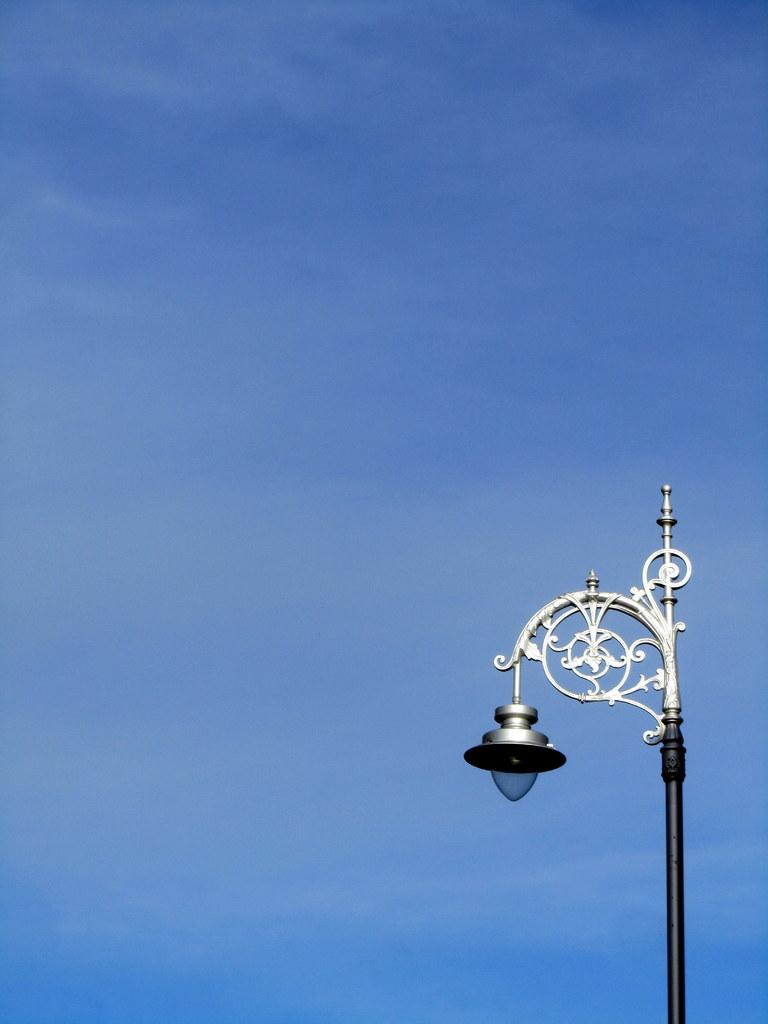What is the source of light in the image? There is a light in the image. What structure is present in the image that might support the light? There is a pole in the image. What is visible in the background of the image? The sky is visible in the image. What grade did the cook receive for their country-style dish in the image? There is no cook or dish present in the image, and therefore no grade can be assigned. 